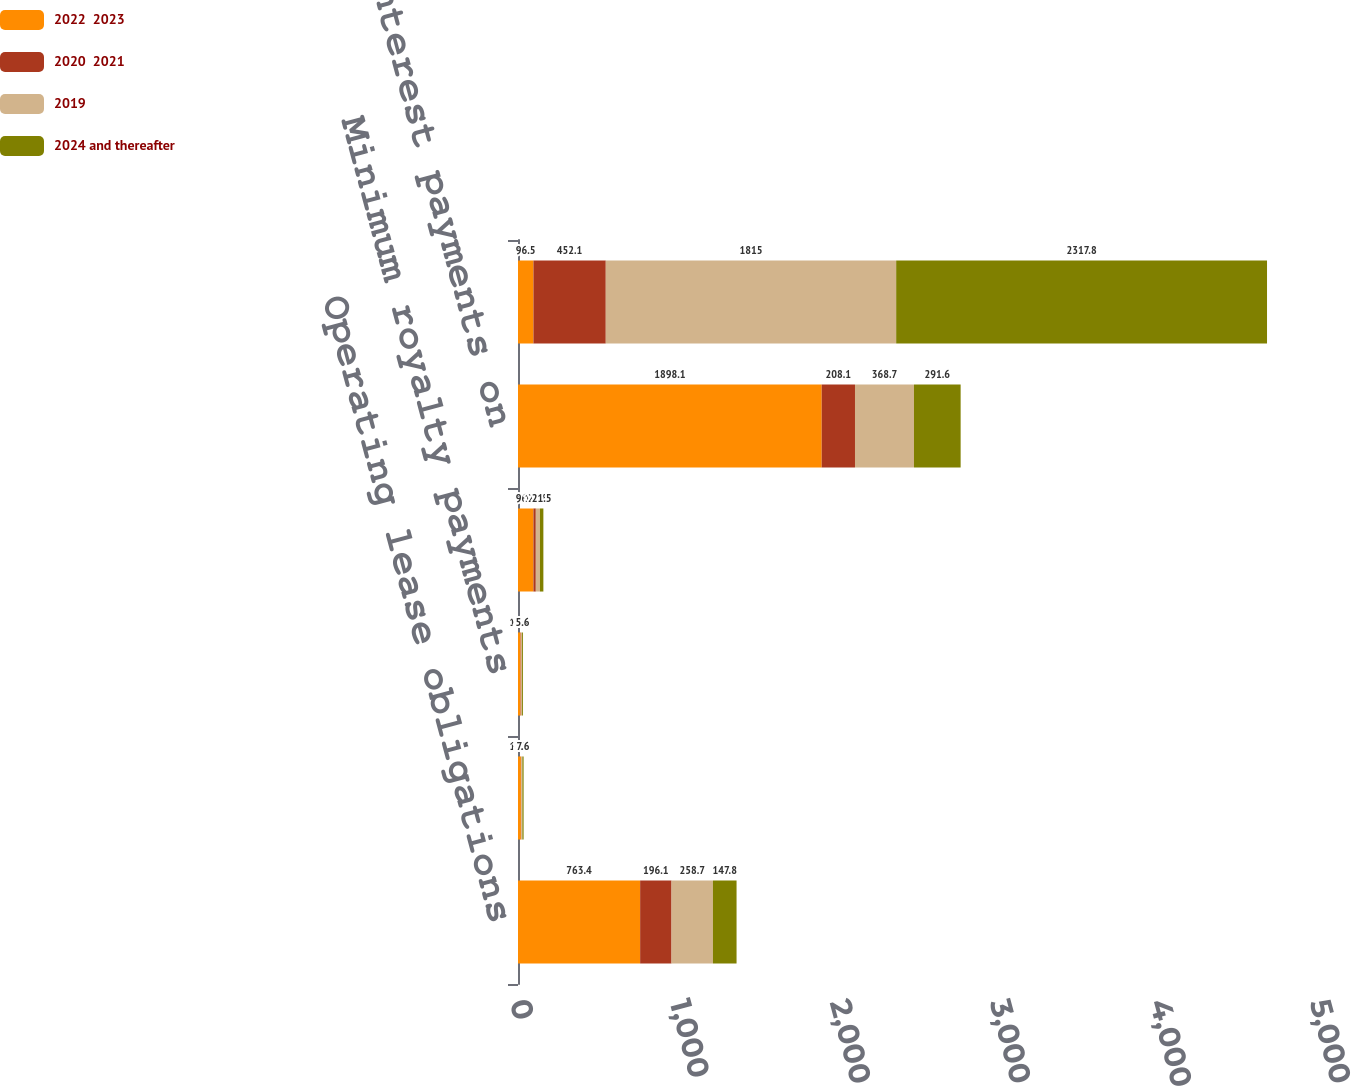Convert chart. <chart><loc_0><loc_0><loc_500><loc_500><stacked_bar_chart><ecel><fcel>Operating lease obligations<fcel>Contingent future licensing<fcel>Minimum royalty payments<fcel>Capital lease obligations<fcel>Scheduled interest payments on<fcel>Total contractual cash<nl><fcel>2022  2023<fcel>763.4<fcel>18.1<fcel>15.8<fcel>96.5<fcel>1898.1<fcel>96.5<nl><fcel>2020  2021<fcel>196.1<fcel>1.6<fcel>2.3<fcel>14.8<fcel>208.1<fcel>452.1<nl><fcel>2019<fcel>258.7<fcel>7.7<fcel>7.6<fcel>25.8<fcel>368.7<fcel>1815<nl><fcel>2024 and thereafter<fcel>147.8<fcel>7.6<fcel>5.6<fcel>21.5<fcel>291.6<fcel>2317.8<nl></chart> 